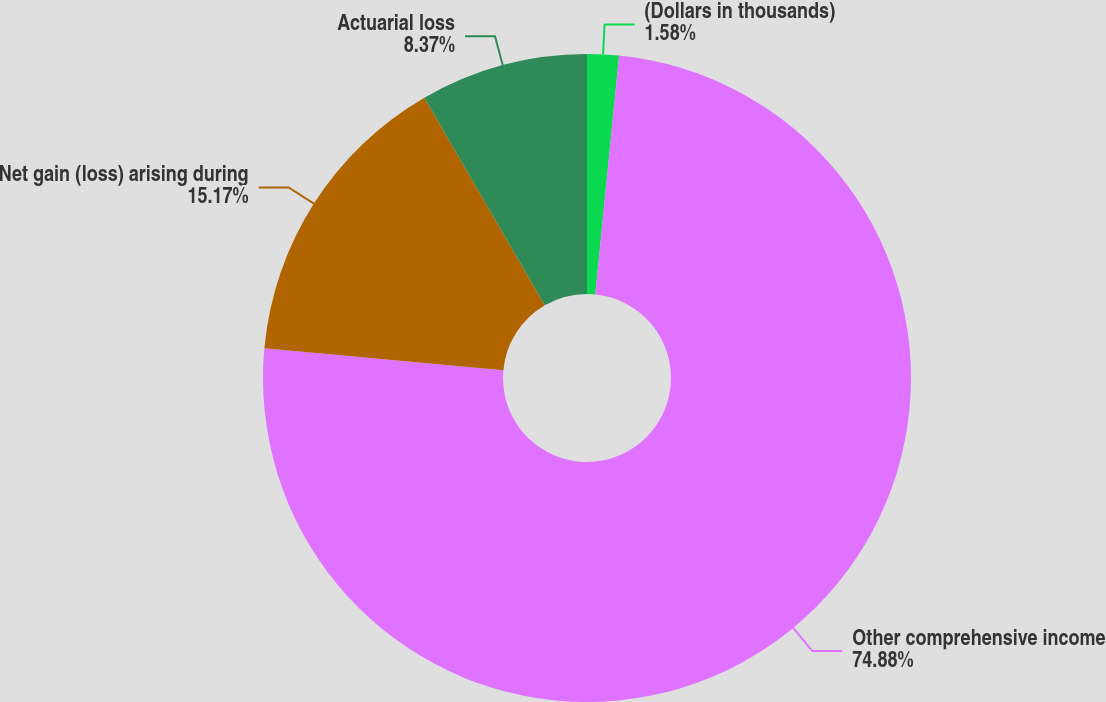Convert chart to OTSL. <chart><loc_0><loc_0><loc_500><loc_500><pie_chart><fcel>(Dollars in thousands)<fcel>Other comprehensive income<fcel>Net gain (loss) arising during<fcel>Actuarial loss<nl><fcel>1.58%<fcel>74.88%<fcel>15.17%<fcel>8.37%<nl></chart> 